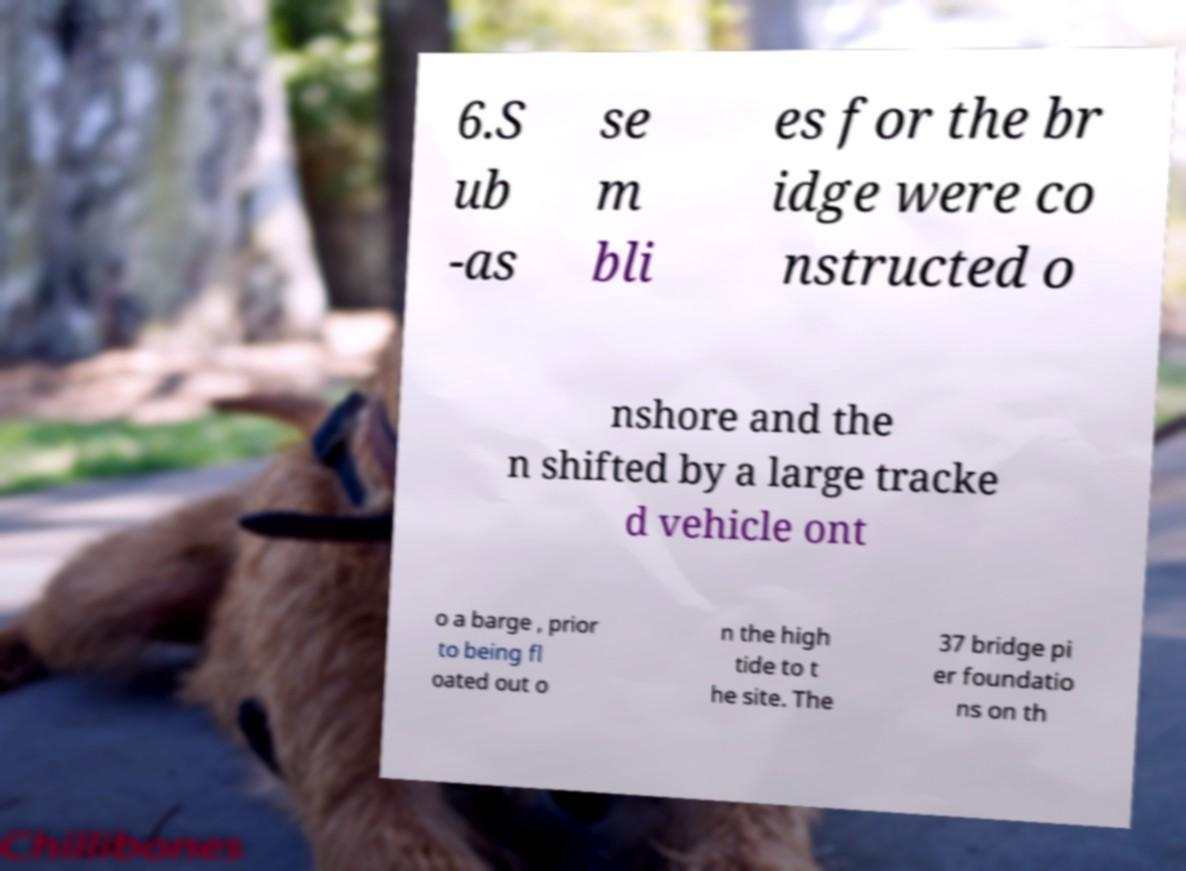For documentation purposes, I need the text within this image transcribed. Could you provide that? 6.S ub -as se m bli es for the br idge were co nstructed o nshore and the n shifted by a large tracke d vehicle ont o a barge , prior to being fl oated out o n the high tide to t he site. The 37 bridge pi er foundatio ns on th 